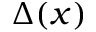Convert formula to latex. <formula><loc_0><loc_0><loc_500><loc_500>\Delta ( x )</formula> 